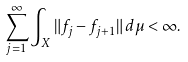Convert formula to latex. <formula><loc_0><loc_0><loc_500><loc_500>\sum _ { j = 1 } ^ { \infty } \int _ { X } \| f _ { j } - f _ { j + 1 } \| \, d \mu < \infty .</formula> 